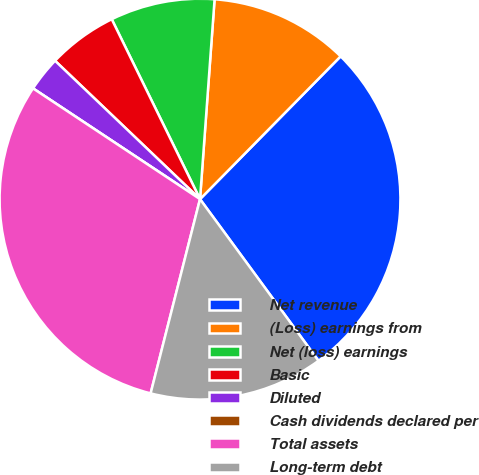<chart> <loc_0><loc_0><loc_500><loc_500><pie_chart><fcel>Net revenue<fcel>(Loss) earnings from<fcel>Net (loss) earnings<fcel>Basic<fcel>Diluted<fcel>Cash dividends declared per<fcel>Total assets<fcel>Long-term debt<nl><fcel>27.56%<fcel>11.22%<fcel>8.42%<fcel>5.61%<fcel>2.81%<fcel>0.0%<fcel>30.36%<fcel>14.03%<nl></chart> 